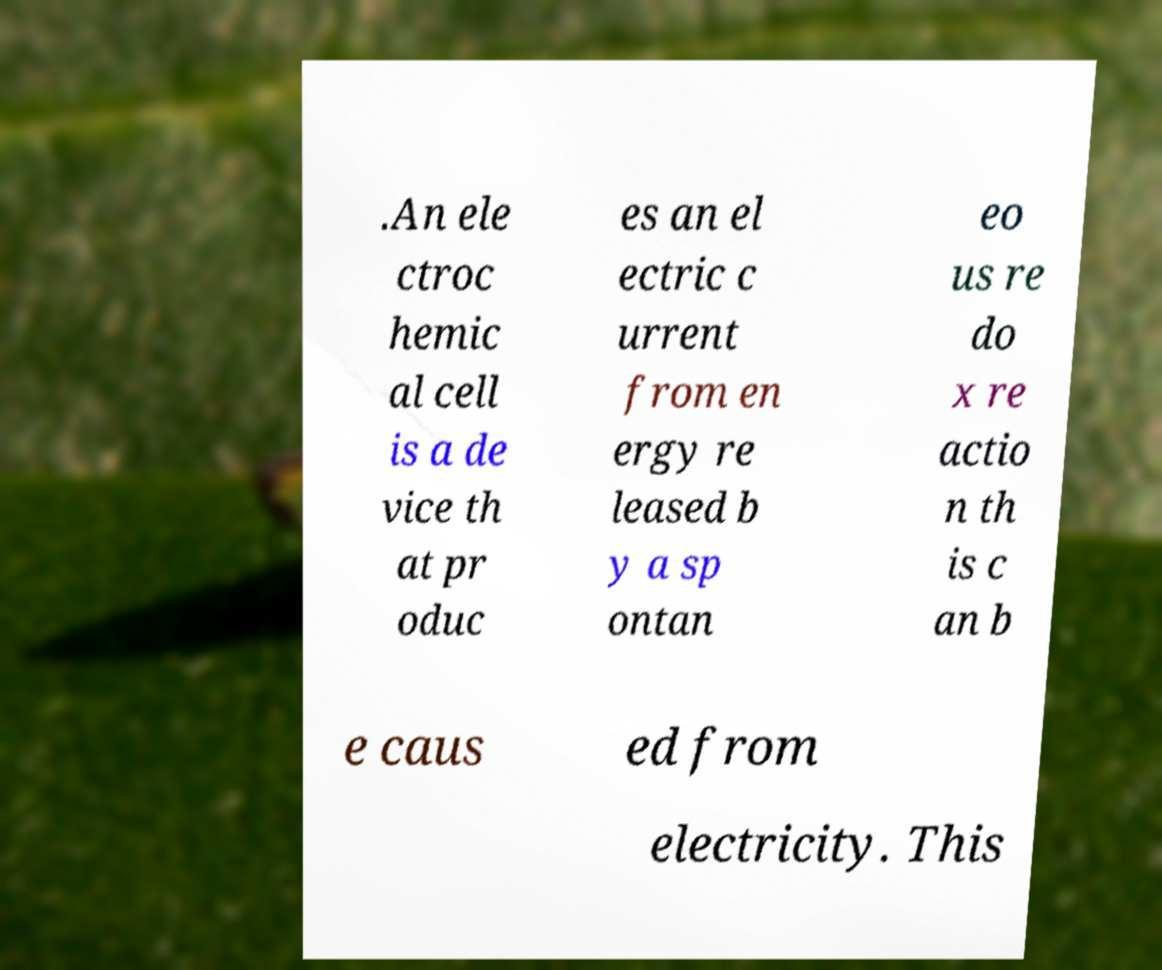Can you read and provide the text displayed in the image?This photo seems to have some interesting text. Can you extract and type it out for me? .An ele ctroc hemic al cell is a de vice th at pr oduc es an el ectric c urrent from en ergy re leased b y a sp ontan eo us re do x re actio n th is c an b e caus ed from electricity. This 